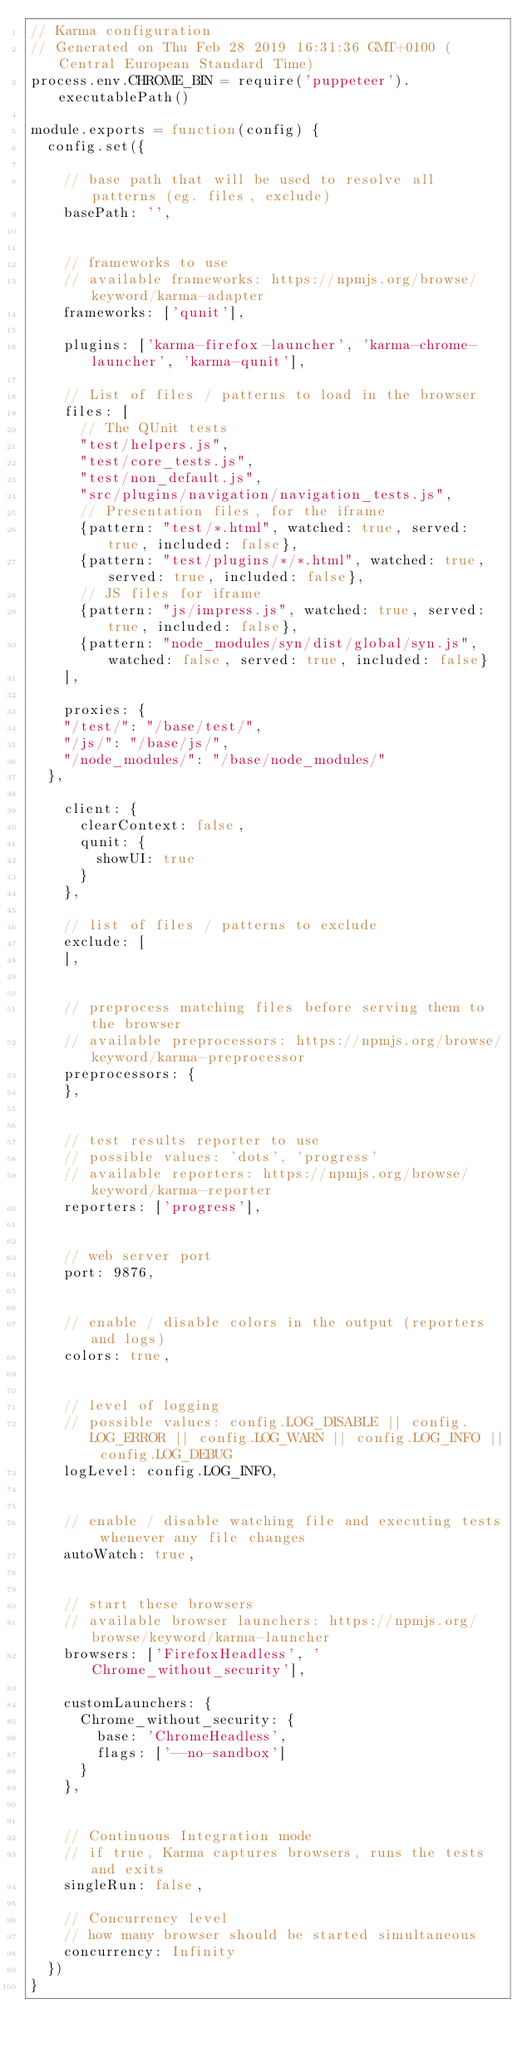Convert code to text. <code><loc_0><loc_0><loc_500><loc_500><_JavaScript_>// Karma configuration
// Generated on Thu Feb 28 2019 16:31:36 GMT+0100 (Central European Standard Time)
process.env.CHROME_BIN = require('puppeteer').executablePath()

module.exports = function(config) {
  config.set({

    // base path that will be used to resolve all patterns (eg. files, exclude)
    basePath: '',


    // frameworks to use
    // available frameworks: https://npmjs.org/browse/keyword/karma-adapter
    frameworks: ['qunit'],

    plugins: ['karma-firefox-launcher', 'karma-chrome-launcher', 'karma-qunit'],

    // List of files / patterns to load in the browser
    files: [
      // The QUnit tests
      "test/helpers.js",
      "test/core_tests.js",
      "test/non_default.js",
      "src/plugins/navigation/navigation_tests.js",
      // Presentation files, for the iframe
      {pattern: "test/*.html", watched: true, served: true, included: false},
      {pattern: "test/plugins/*/*.html", watched: true, served: true, included: false},
      // JS files for iframe
      {pattern: "js/impress.js", watched: true, served: true, included: false},
      {pattern: "node_modules/syn/dist/global/syn.js", watched: false, served: true, included: false}
    ],

    proxies: {
    "/test/": "/base/test/",
    "/js/": "/base/js/",
    "/node_modules/": "/base/node_modules/"
  },
    
    client: {
      clearContext: false,
      qunit: {
        showUI: true
      }
    },

    // list of files / patterns to exclude
    exclude: [
    ],


    // preprocess matching files before serving them to the browser
    // available preprocessors: https://npmjs.org/browse/keyword/karma-preprocessor
    preprocessors: {
    },


    // test results reporter to use
    // possible values: 'dots', 'progress'
    // available reporters: https://npmjs.org/browse/keyword/karma-reporter
    reporters: ['progress'],


    // web server port
    port: 9876,


    // enable / disable colors in the output (reporters and logs)
    colors: true,


    // level of logging
    // possible values: config.LOG_DISABLE || config.LOG_ERROR || config.LOG_WARN || config.LOG_INFO || config.LOG_DEBUG
    logLevel: config.LOG_INFO,


    // enable / disable watching file and executing tests whenever any file changes
    autoWatch: true,


    // start these browsers
    // available browser launchers: https://npmjs.org/browse/keyword/karma-launcher
    browsers: ['FirefoxHeadless', 'Chrome_without_security'],

    customLaunchers: {
      Chrome_without_security: {
        base: 'ChromeHeadless',
        flags: ['--no-sandbox']
      }
    },


    // Continuous Integration mode
    // if true, Karma captures browsers, runs the tests and exits
    singleRun: false,

    // Concurrency level
    // how many browser should be started simultaneous
    concurrency: Infinity
  })
}
</code> 